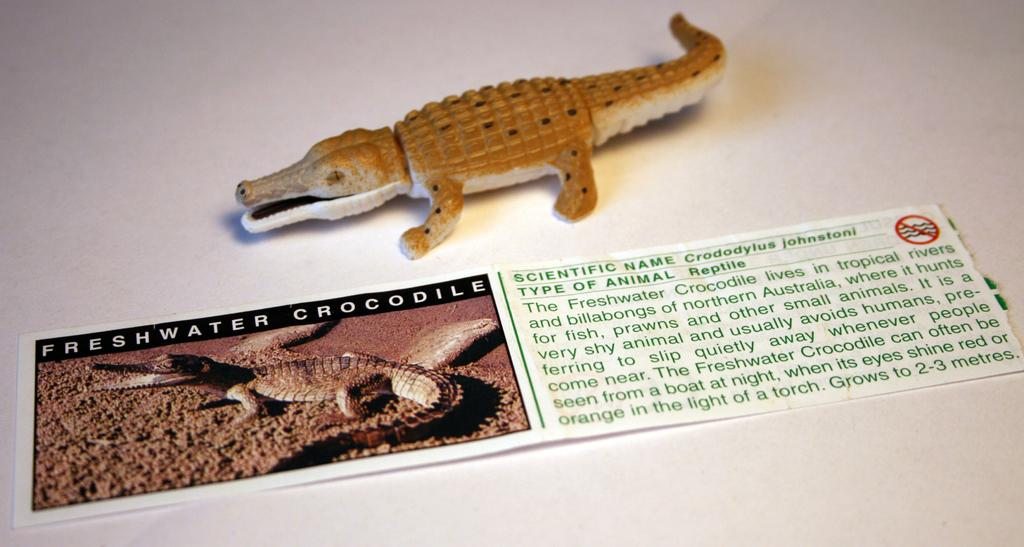What type of toy is present in the image? There is a toy lizard in the image. What else can be seen in the image besides the toy lizard? There is a paper in the image. What is depicted on the paper? The paper has a lizard image on it. Is there any text on the paper? Yes, there is text written on the paper. What type of scent can be detected from the toy lizard in the image? Toys do not have scents, so there is no scent detectable from the toy lizard in the image. 